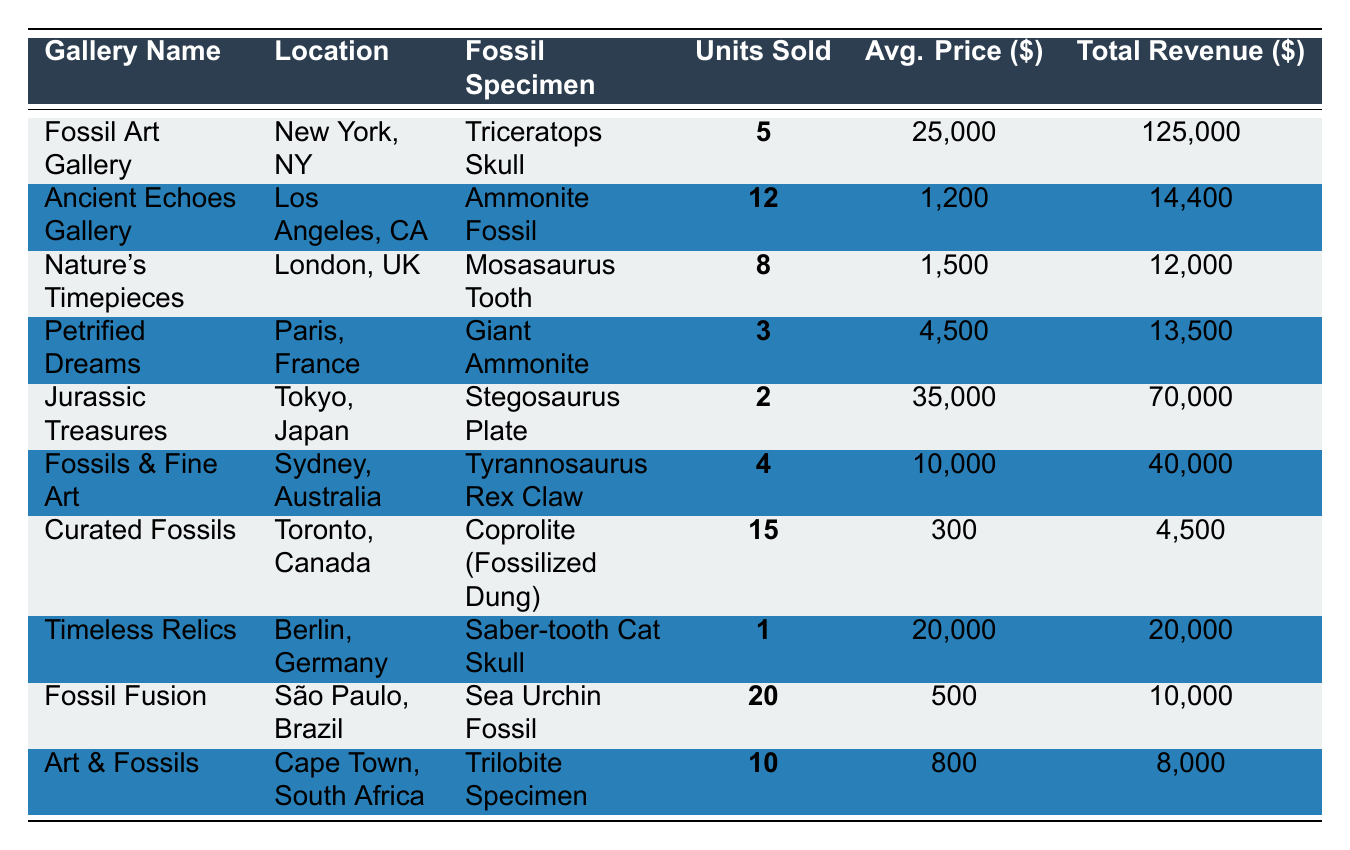What fossil specimen had the highest units sold? By checking the "Units Sold" column, I see that the highest value is 20, corresponding to the "Sea Urchin Fossil" at "Fossil Fusion" gallery.
Answer: Sea Urchin Fossil Which gallery sold more than 10 units? Looking at the "Units Sold" column, "Ancient Echoes Gallery" sold 12 units and "Curated Fossils" sold 15 units.
Answer: Ancient Echoes Gallery and Curated Fossils What is the total revenue generated from all sales? To find the total revenue, I add up all the values in the "Total Revenue" column: (125000 + 14400 + 12000 + 13500 + 70000 + 40000 + 4500 + 20000 + 10000 + 8000) = 320400.
Answer: 320400 Which fossil specimen had the highest average price? I scan the "Avg. Price" column and find the highest value is 35000 for "Stegosaurus Plate" sold by "Jurassic Treasures."
Answer: Stegosaurus Plate How many more units of the "Ammonite Fossil" were sold compared to the "Giant Ammonite"? The "Ammonite Fossil" had 12 units sold, and the "Giant Ammonite" had 3. The difference is 12 - 3 = 9.
Answer: 9 Is there a gallery located in Berlin? Yes, "Timeless Relics" is situated in Berlin, Germany.
Answer: Yes What is the average price of fossils sold by "Fossils & Fine Art"? The average price of the "Tyrannosaurus Rex Claw" sold is noted as 10000, and since only one fossil was sold by that gallery, it's also the average price.
Answer: 10000 Which two galleries generated the most revenue and what is their combined total? By looking through the "Total Revenue" column, "Fossil Art Gallery" generated 125000 and "Jurassic Treasures" generated 70000. Adding these together: 125000 + 70000 = 195000.
Answer: 195000 Did "Curated Fossils" generate more revenue than "Art & Fossils"? "Curated Fossils" generated 4500, while "Art & Fossils" generated 8000. Therefore, the answer is no.
Answer: No What percentage of total revenue came from "Fossil Fusion"? "Fossil Fusion" generated 10000. To find the percentage: (10000 / 320400) * 100 ≈ 3.12%.
Answer: 3.12% 